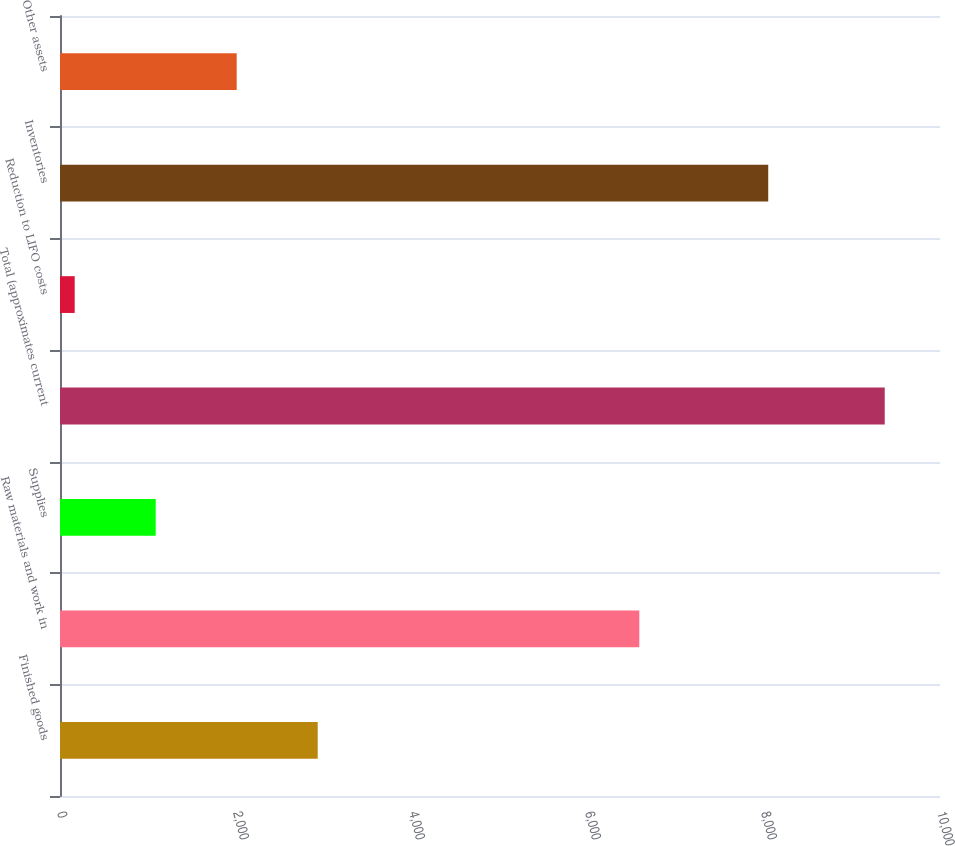<chart> <loc_0><loc_0><loc_500><loc_500><bar_chart><fcel>Finished goods<fcel>Raw materials and work in<fcel>Supplies<fcel>Total (approximates current<fcel>Reduction to LIFO costs<fcel>Inventories<fcel>Other assets<nl><fcel>2928.5<fcel>6583<fcel>1087.5<fcel>9372<fcel>167<fcel>8048<fcel>2008<nl></chart> 